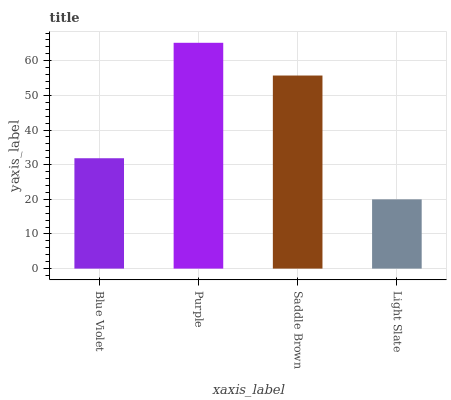Is Saddle Brown the minimum?
Answer yes or no. No. Is Saddle Brown the maximum?
Answer yes or no. No. Is Purple greater than Saddle Brown?
Answer yes or no. Yes. Is Saddle Brown less than Purple?
Answer yes or no. Yes. Is Saddle Brown greater than Purple?
Answer yes or no. No. Is Purple less than Saddle Brown?
Answer yes or no. No. Is Saddle Brown the high median?
Answer yes or no. Yes. Is Blue Violet the low median?
Answer yes or no. Yes. Is Blue Violet the high median?
Answer yes or no. No. Is Saddle Brown the low median?
Answer yes or no. No. 